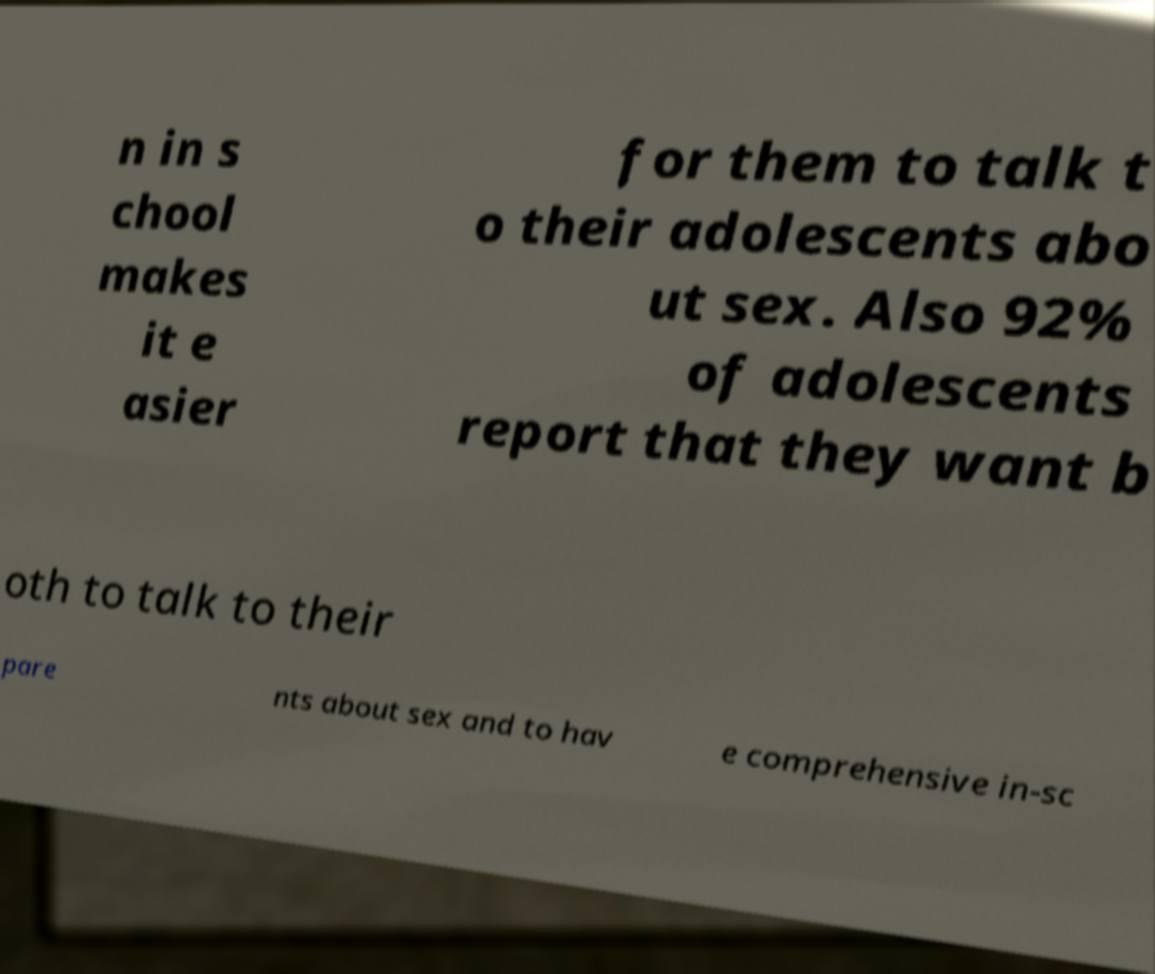Could you assist in decoding the text presented in this image and type it out clearly? n in s chool makes it e asier for them to talk t o their adolescents abo ut sex. Also 92% of adolescents report that they want b oth to talk to their pare nts about sex and to hav e comprehensive in-sc 